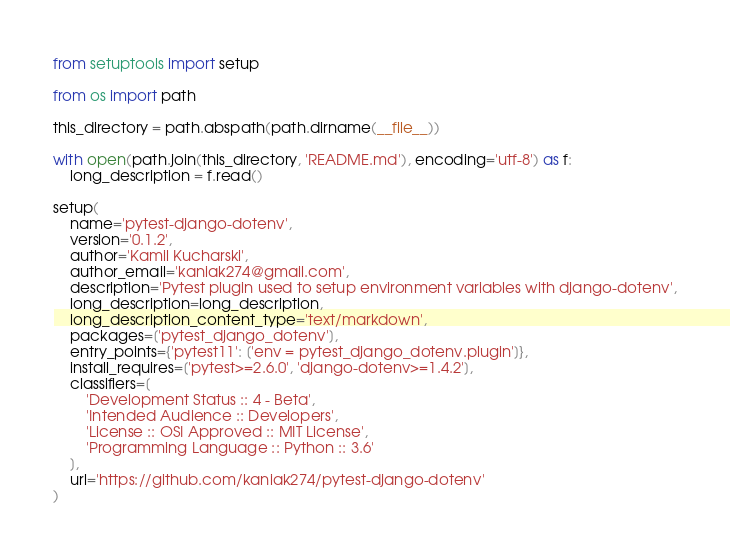Convert code to text. <code><loc_0><loc_0><loc_500><loc_500><_Python_>from setuptools import setup

from os import path

this_directory = path.abspath(path.dirname(__file__))

with open(path.join(this_directory, 'README.md'), encoding='utf-8') as f:
    long_description = f.read()

setup(
    name='pytest-django-dotenv',
    version='0.1.2',
    author='Kamil Kucharski',
    author_email='kaniak274@gmail.com',
    description='Pytest plugin used to setup environment variables with django-dotenv',
    long_description=long_description,
    long_description_content_type='text/markdown',
    packages=['pytest_django_dotenv'],
    entry_points={'pytest11': ['env = pytest_django_dotenv.plugin']},
    install_requires=['pytest>=2.6.0', 'django-dotenv>=1.4.2'],
    classifiers=[
        'Development Status :: 4 - Beta',
        'Intended Audience :: Developers',
        'License :: OSI Approved :: MIT License',
        'Programming Language :: Python :: 3.6'
    ],
    url='https://github.com/kaniak274/pytest-django-dotenv'
)
</code> 